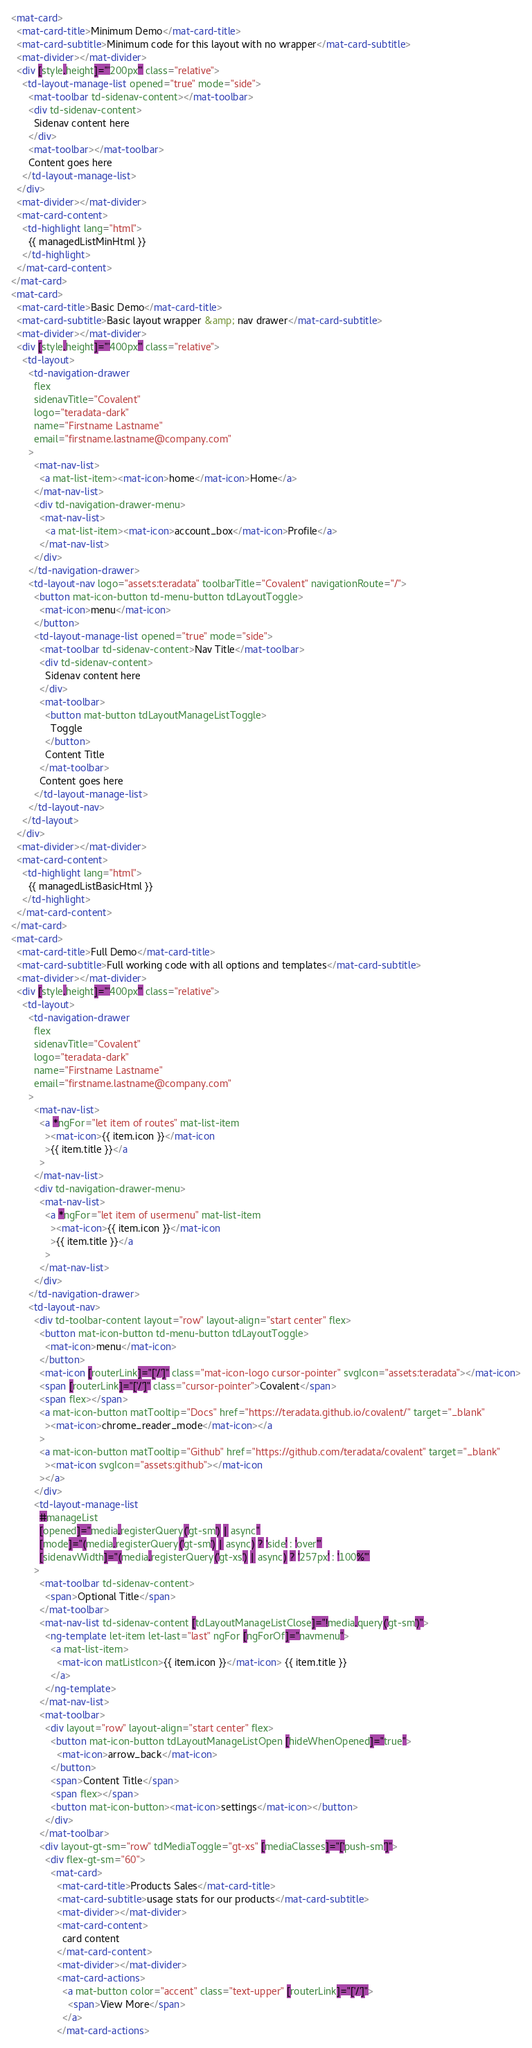Convert code to text. <code><loc_0><loc_0><loc_500><loc_500><_HTML_><mat-card>
  <mat-card-title>Minimum Demo</mat-card-title>
  <mat-card-subtitle>Minimum code for this layout with no wrapper</mat-card-subtitle>
  <mat-divider></mat-divider>
  <div [style.height]="'200px'" class="relative">
    <td-layout-manage-list opened="true" mode="side">
      <mat-toolbar td-sidenav-content></mat-toolbar>
      <div td-sidenav-content>
        Sidenav content here
      </div>
      <mat-toolbar></mat-toolbar>
      Content goes here
    </td-layout-manage-list>
  </div>
  <mat-divider></mat-divider>
  <mat-card-content>
    <td-highlight lang="html">
      {{ managedListMinHtml }}
    </td-highlight>
  </mat-card-content>
</mat-card>
<mat-card>
  <mat-card-title>Basic Demo</mat-card-title>
  <mat-card-subtitle>Basic layout wrapper &amp; nav drawer</mat-card-subtitle>
  <mat-divider></mat-divider>
  <div [style.height]="'400px'" class="relative">
    <td-layout>
      <td-navigation-drawer
        flex
        sidenavTitle="Covalent"
        logo="teradata-dark"
        name="Firstname Lastname"
        email="firstname.lastname@company.com"
      >
        <mat-nav-list>
          <a mat-list-item><mat-icon>home</mat-icon>Home</a>
        </mat-nav-list>
        <div td-navigation-drawer-menu>
          <mat-nav-list>
            <a mat-list-item><mat-icon>account_box</mat-icon>Profile</a>
          </mat-nav-list>
        </div>
      </td-navigation-drawer>
      <td-layout-nav logo="assets:teradata" toolbarTitle="Covalent" navigationRoute="/">
        <button mat-icon-button td-menu-button tdLayoutToggle>
          <mat-icon>menu</mat-icon>
        </button>
        <td-layout-manage-list opened="true" mode="side">
          <mat-toolbar td-sidenav-content>Nav Title</mat-toolbar>
          <div td-sidenav-content>
            Sidenav content here
          </div>
          <mat-toolbar>
            <button mat-button tdLayoutManageListToggle>
              Toggle
            </button>
            Content Title
          </mat-toolbar>
          Content goes here
        </td-layout-manage-list>
      </td-layout-nav>
    </td-layout>
  </div>
  <mat-divider></mat-divider>
  <mat-card-content>
    <td-highlight lang="html">
      {{ managedListBasicHtml }}
    </td-highlight>
  </mat-card-content>
</mat-card>
<mat-card>
  <mat-card-title>Full Demo</mat-card-title>
  <mat-card-subtitle>Full working code with all options and templates</mat-card-subtitle>
  <mat-divider></mat-divider>
  <div [style.height]="'400px'" class="relative">
    <td-layout>
      <td-navigation-drawer
        flex
        sidenavTitle="Covalent"
        logo="teradata-dark"
        name="Firstname Lastname"
        email="firstname.lastname@company.com"
      >
        <mat-nav-list>
          <a *ngFor="let item of routes" mat-list-item
            ><mat-icon>{{ item.icon }}</mat-icon
            >{{ item.title }}</a
          >
        </mat-nav-list>
        <div td-navigation-drawer-menu>
          <mat-nav-list>
            <a *ngFor="let item of usermenu" mat-list-item
              ><mat-icon>{{ item.icon }}</mat-icon
              >{{ item.title }}</a
            >
          </mat-nav-list>
        </div>
      </td-navigation-drawer>
      <td-layout-nav>
        <div td-toolbar-content layout="row" layout-align="start center" flex>
          <button mat-icon-button td-menu-button tdLayoutToggle>
            <mat-icon>menu</mat-icon>
          </button>
          <mat-icon [routerLink]="['/']" class="mat-icon-logo cursor-pointer" svgIcon="assets:teradata"></mat-icon>
          <span [routerLink]="['/']" class="cursor-pointer">Covalent</span>
          <span flex></span>
          <a mat-icon-button matTooltip="Docs" href="https://teradata.github.io/covalent/" target="_blank"
            ><mat-icon>chrome_reader_mode</mat-icon></a
          >
          <a mat-icon-button matTooltip="Github" href="https://github.com/teradata/covalent" target="_blank"
            ><mat-icon svgIcon="assets:github"></mat-icon
          ></a>
        </div>
        <td-layout-manage-list
          #manageList
          [opened]="media.registerQuery('gt-sm') | async"
          [mode]="(media.registerQuery('gt-sm') | async) ? 'side' : 'over'"
          [sidenavWidth]="(media.registerQuery('gt-xs') | async) ? '257px' : '100%'"
        >
          <mat-toolbar td-sidenav-content>
            <span>Optional Title</span>
          </mat-toolbar>
          <mat-nav-list td-sidenav-content [tdLayoutManageListClose]="!media.query('gt-sm')">
            <ng-template let-item let-last="last" ngFor [ngForOf]="navmenu">
              <a mat-list-item>
                <mat-icon matListIcon>{{ item.icon }}</mat-icon> {{ item.title }}
              </a>
            </ng-template>
          </mat-nav-list>
          <mat-toolbar>
            <div layout="row" layout-align="start center" flex>
              <button mat-icon-button tdLayoutManageListOpen [hideWhenOpened]="true">
                <mat-icon>arrow_back</mat-icon>
              </button>
              <span>Content Title</span>
              <span flex></span>
              <button mat-icon-button><mat-icon>settings</mat-icon></button>
            </div>
          </mat-toolbar>
          <div layout-gt-sm="row" tdMediaToggle="gt-xs" [mediaClasses]="['push-sm']">
            <div flex-gt-sm="60">
              <mat-card>
                <mat-card-title>Products Sales</mat-card-title>
                <mat-card-subtitle>usage stats for our products</mat-card-subtitle>
                <mat-divider></mat-divider>
                <mat-card-content>
                  card content
                </mat-card-content>
                <mat-divider></mat-divider>
                <mat-card-actions>
                  <a mat-button color="accent" class="text-upper" [routerLink]="['/']">
                    <span>View More</span>
                  </a>
                </mat-card-actions></code> 